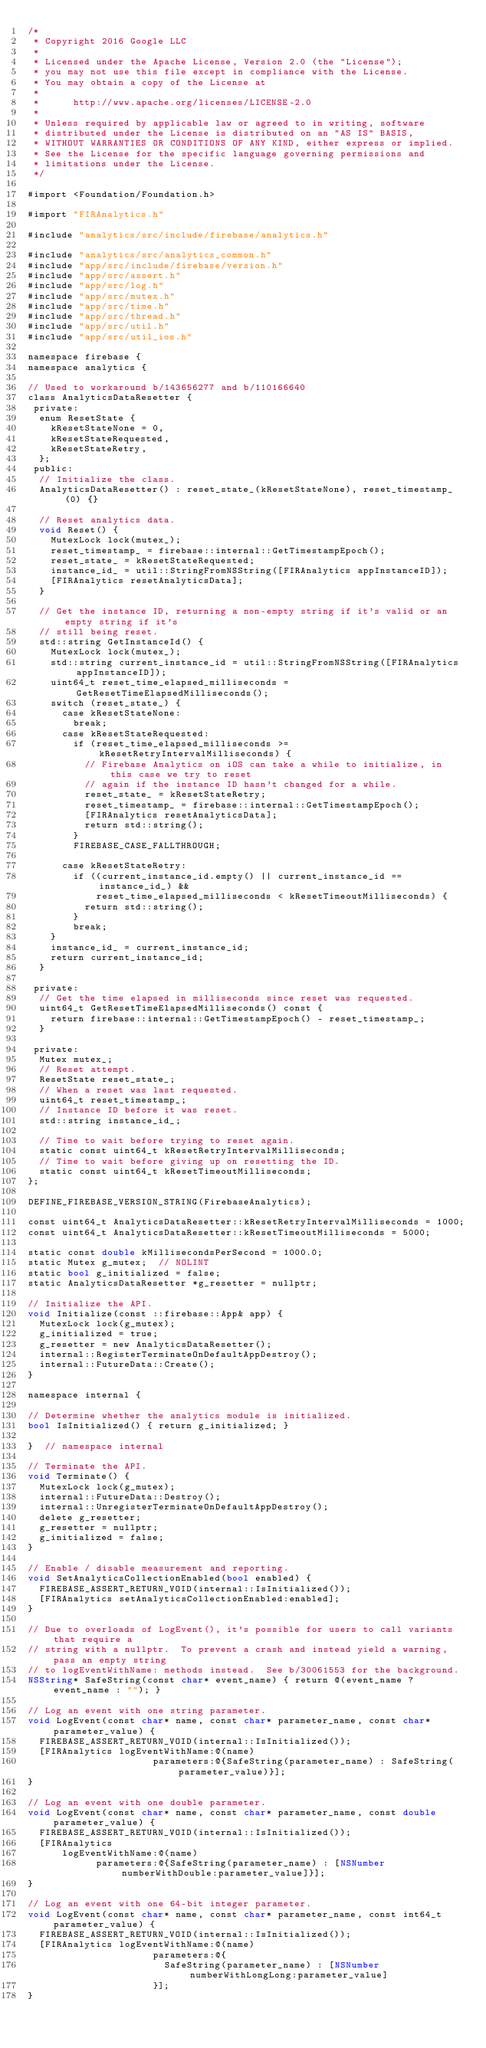<code> <loc_0><loc_0><loc_500><loc_500><_ObjectiveC_>/*
 * Copyright 2016 Google LLC
 *
 * Licensed under the Apache License, Version 2.0 (the "License");
 * you may not use this file except in compliance with the License.
 * You may obtain a copy of the License at
 *
 *      http://www.apache.org/licenses/LICENSE-2.0
 *
 * Unless required by applicable law or agreed to in writing, software
 * distributed under the License is distributed on an "AS IS" BASIS,
 * WITHOUT WARRANTIES OR CONDITIONS OF ANY KIND, either express or implied.
 * See the License for the specific language governing permissions and
 * limitations under the License.
 */

#import <Foundation/Foundation.h>

#import "FIRAnalytics.h"

#include "analytics/src/include/firebase/analytics.h"

#include "analytics/src/analytics_common.h"
#include "app/src/include/firebase/version.h"
#include "app/src/assert.h"
#include "app/src/log.h"
#include "app/src/mutex.h"
#include "app/src/time.h"
#include "app/src/thread.h"
#include "app/src/util.h"
#include "app/src/util_ios.h"

namespace firebase {
namespace analytics {

// Used to workaround b/143656277 and b/110166640
class AnalyticsDataResetter {
 private:
  enum ResetState {
    kResetStateNone = 0,
    kResetStateRequested,
    kResetStateRetry,
  };
 public:
  // Initialize the class.
  AnalyticsDataResetter() : reset_state_(kResetStateNone), reset_timestamp_(0) {}

  // Reset analytics data.
  void Reset() {
    MutexLock lock(mutex_);
    reset_timestamp_ = firebase::internal::GetTimestampEpoch();
    reset_state_ = kResetStateRequested;
    instance_id_ = util::StringFromNSString([FIRAnalytics appInstanceID]);
    [FIRAnalytics resetAnalyticsData];
  }

  // Get the instance ID, returning a non-empty string if it's valid or an empty string if it's
  // still being reset.
  std::string GetInstanceId() {
    MutexLock lock(mutex_);
    std::string current_instance_id = util::StringFromNSString([FIRAnalytics appInstanceID]);
    uint64_t reset_time_elapsed_milliseconds = GetResetTimeElapsedMilliseconds();
    switch (reset_state_) {
      case kResetStateNone:
        break;
      case kResetStateRequested:
        if (reset_time_elapsed_milliseconds >= kResetRetryIntervalMilliseconds) {
          // Firebase Analytics on iOS can take a while to initialize, in this case we try to reset
          // again if the instance ID hasn't changed for a while.
          reset_state_ = kResetStateRetry;
          reset_timestamp_ = firebase::internal::GetTimestampEpoch();
          [FIRAnalytics resetAnalyticsData];
          return std::string();
        }
        FIREBASE_CASE_FALLTHROUGH;

      case kResetStateRetry:
        if ((current_instance_id.empty() || current_instance_id == instance_id_) &&
            reset_time_elapsed_milliseconds < kResetTimeoutMilliseconds) {
          return std::string();
        }
        break;
    }
    instance_id_ = current_instance_id;
    return current_instance_id;
  }

 private:
  // Get the time elapsed in milliseconds since reset was requested.
  uint64_t GetResetTimeElapsedMilliseconds() const {
    return firebase::internal::GetTimestampEpoch() - reset_timestamp_;
  }

 private:
  Mutex mutex_;
  // Reset attempt.
  ResetState reset_state_;
  // When a reset was last requested.
  uint64_t reset_timestamp_;
  // Instance ID before it was reset.
  std::string instance_id_;

  // Time to wait before trying to reset again.
  static const uint64_t kResetRetryIntervalMilliseconds;
  // Time to wait before giving up on resetting the ID.
  static const uint64_t kResetTimeoutMilliseconds;
};

DEFINE_FIREBASE_VERSION_STRING(FirebaseAnalytics);

const uint64_t AnalyticsDataResetter::kResetRetryIntervalMilliseconds = 1000;
const uint64_t AnalyticsDataResetter::kResetTimeoutMilliseconds = 5000;

static const double kMillisecondsPerSecond = 1000.0;
static Mutex g_mutex;  // NOLINT
static bool g_initialized = false;
static AnalyticsDataResetter *g_resetter = nullptr;

// Initialize the API.
void Initialize(const ::firebase::App& app) {
  MutexLock lock(g_mutex);
  g_initialized = true;
  g_resetter = new AnalyticsDataResetter();
  internal::RegisterTerminateOnDefaultAppDestroy();
  internal::FutureData::Create();
}

namespace internal {

// Determine whether the analytics module is initialized.
bool IsInitialized() { return g_initialized; }

}  // namespace internal

// Terminate the API.
void Terminate() {
  MutexLock lock(g_mutex);
  internal::FutureData::Destroy();
  internal::UnregisterTerminateOnDefaultAppDestroy();
  delete g_resetter;
  g_resetter = nullptr;
  g_initialized = false;
}

// Enable / disable measurement and reporting.
void SetAnalyticsCollectionEnabled(bool enabled) {
  FIREBASE_ASSERT_RETURN_VOID(internal::IsInitialized());
  [FIRAnalytics setAnalyticsCollectionEnabled:enabled];
}

// Due to overloads of LogEvent(), it's possible for users to call variants that require a
// string with a nullptr.  To prevent a crash and instead yield a warning, pass an empty string
// to logEventWithName: methods instead.  See b/30061553 for the background.
NSString* SafeString(const char* event_name) { return @(event_name ? event_name : ""); }

// Log an event with one string parameter.
void LogEvent(const char* name, const char* parameter_name, const char* parameter_value) {
  FIREBASE_ASSERT_RETURN_VOID(internal::IsInitialized());
  [FIRAnalytics logEventWithName:@(name)
                      parameters:@{SafeString(parameter_name) : SafeString(parameter_value)}];
}

// Log an event with one double parameter.
void LogEvent(const char* name, const char* parameter_name, const double parameter_value) {
  FIREBASE_ASSERT_RETURN_VOID(internal::IsInitialized());
  [FIRAnalytics
      logEventWithName:@(name)
            parameters:@{SafeString(parameter_name) : [NSNumber numberWithDouble:parameter_value]}];
}

// Log an event with one 64-bit integer parameter.
void LogEvent(const char* name, const char* parameter_name, const int64_t parameter_value) {
  FIREBASE_ASSERT_RETURN_VOID(internal::IsInitialized());
  [FIRAnalytics logEventWithName:@(name)
                      parameters:@{
                        SafeString(parameter_name) : [NSNumber numberWithLongLong:parameter_value]
                      }];
}
</code> 